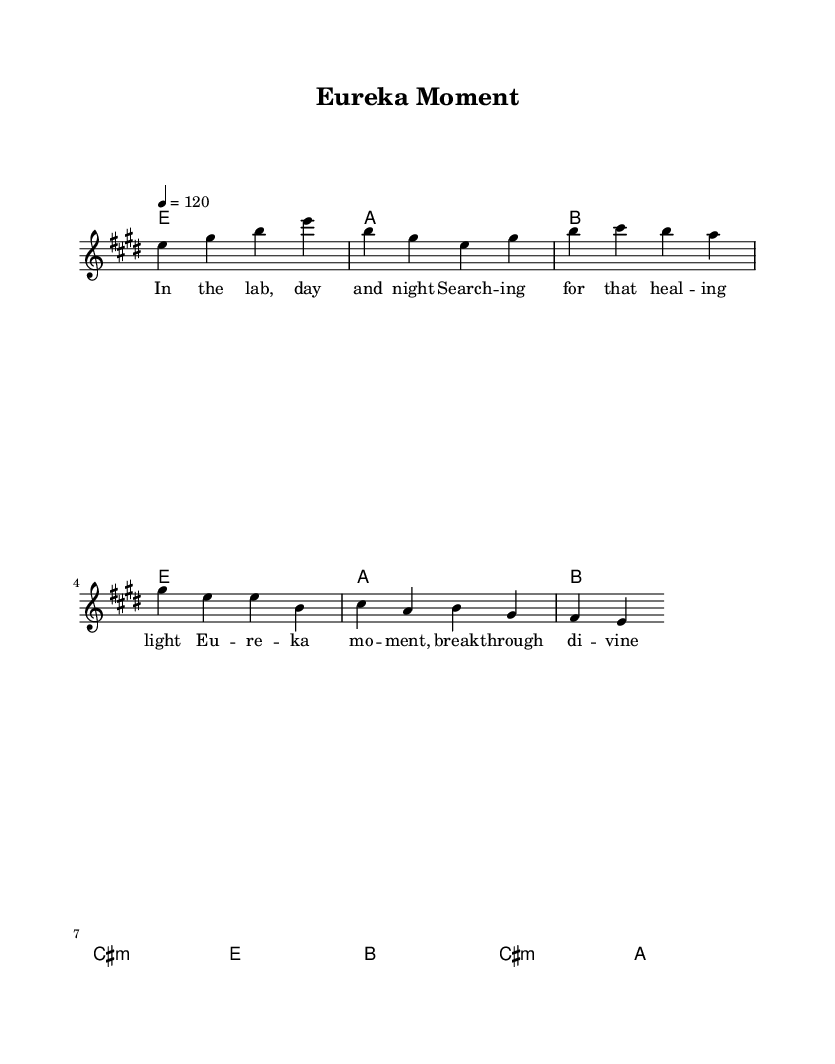What is the key signature of this music? The key signature is E major, indicated by four sharps in the key signature.
Answer: E major What is the time signature of this music? The time signature is 4/4, which is indicated at the beginning of the score.
Answer: 4/4 What is the tempo of the piece? The tempo is indicated as quarter note equals 120 beats per minute, which sets the speed of the piece.
Answer: 120 How many measures are there in the verse section? The verse consists of two lines of lyrics, each containing four measures, totaling eight measures.
Answer: 8 Which chord is used in the chorus? The chords in the chorus include B major, C sharp minor, and A major. The presence of these chords is noted during the chorus section.
Answer: B major, C sharp minor, A major What is the main lyrical theme of the song? The song reflects the experience of searching for medical breakthroughs and the joy of discovery, which is evident in both the verse and chorus lyrics.
Answer: Discovery What musical elements indicate that this is a classic rock song? The chord progression and melody structure, along with the rhythm and lyrical content, evoke classic rock characteristics, such as anthemic choruses and relatable themes.
Answer: Anthemic chorus 